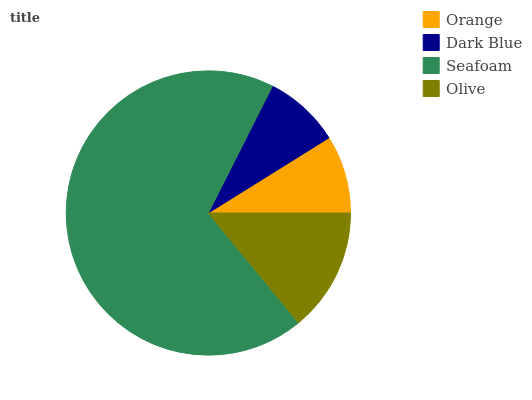Is Dark Blue the minimum?
Answer yes or no. Yes. Is Seafoam the maximum?
Answer yes or no. Yes. Is Seafoam the minimum?
Answer yes or no. No. Is Dark Blue the maximum?
Answer yes or no. No. Is Seafoam greater than Dark Blue?
Answer yes or no. Yes. Is Dark Blue less than Seafoam?
Answer yes or no. Yes. Is Dark Blue greater than Seafoam?
Answer yes or no. No. Is Seafoam less than Dark Blue?
Answer yes or no. No. Is Olive the high median?
Answer yes or no. Yes. Is Orange the low median?
Answer yes or no. Yes. Is Dark Blue the high median?
Answer yes or no. No. Is Olive the low median?
Answer yes or no. No. 